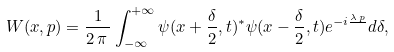<formula> <loc_0><loc_0><loc_500><loc_500>W ( x , p ) = \frac { 1 } { 2 \, \pi \, } \int _ { - \infty } ^ { + \infty } \psi ( x + \frac { \delta } { 2 } , t ) ^ { * } \psi ( x - \frac { \delta } { 2 } , t ) e ^ { - i \frac { \lambda \, p } { } } d \delta ,</formula> 